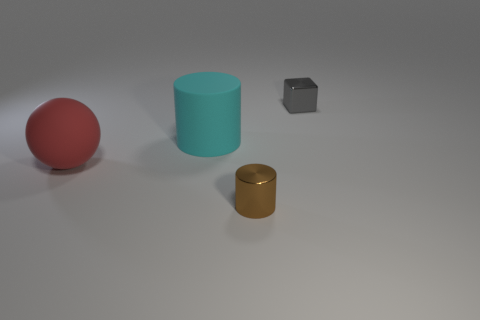There is a matte thing that is the same size as the cyan rubber cylinder; what is its shape?
Ensure brevity in your answer.  Sphere. There is a metallic thing that is to the left of the small block; is its size the same as the matte thing that is in front of the rubber cylinder?
Give a very brief answer. No. There is a big sphere that is made of the same material as the big cylinder; what color is it?
Your answer should be compact. Red. Is the material of the tiny object behind the large red matte thing the same as the small object that is left of the gray shiny thing?
Offer a very short reply. Yes. Is there a rubber cylinder that has the same size as the gray metallic thing?
Provide a succinct answer. No. How big is the metallic thing in front of the metal thing on the right side of the metallic cylinder?
Ensure brevity in your answer.  Small. What number of other metallic cylinders have the same color as the big cylinder?
Keep it short and to the point. 0. There is a tiny thing that is in front of the red object in front of the small gray shiny block; what shape is it?
Ensure brevity in your answer.  Cylinder. How many tiny cylinders are the same material as the tiny gray cube?
Make the answer very short. 1. There is a big object that is on the right side of the large red ball; what is its material?
Give a very brief answer. Rubber. 